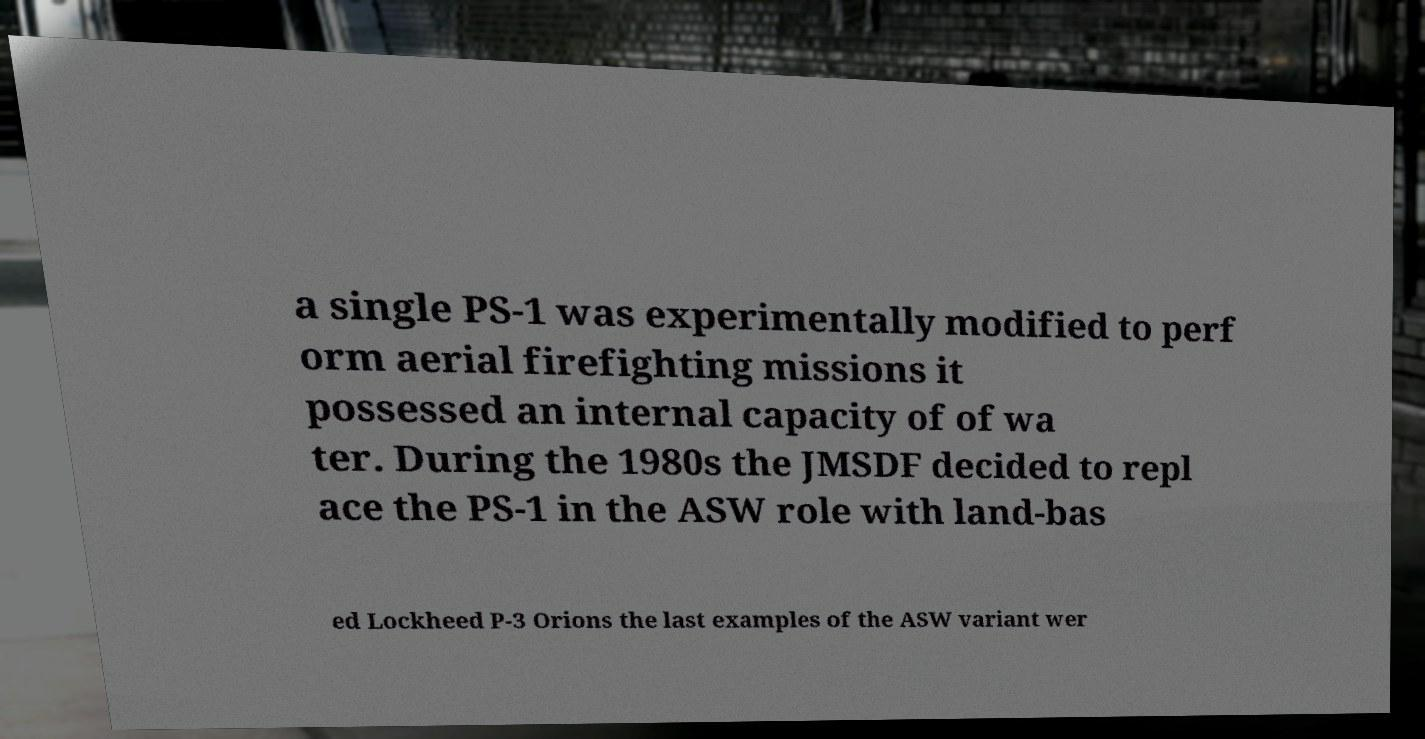What messages or text are displayed in this image? I need them in a readable, typed format. a single PS-1 was experimentally modified to perf orm aerial firefighting missions it possessed an internal capacity of of wa ter. During the 1980s the JMSDF decided to repl ace the PS-1 in the ASW role with land-bas ed Lockheed P-3 Orions the last examples of the ASW variant wer 